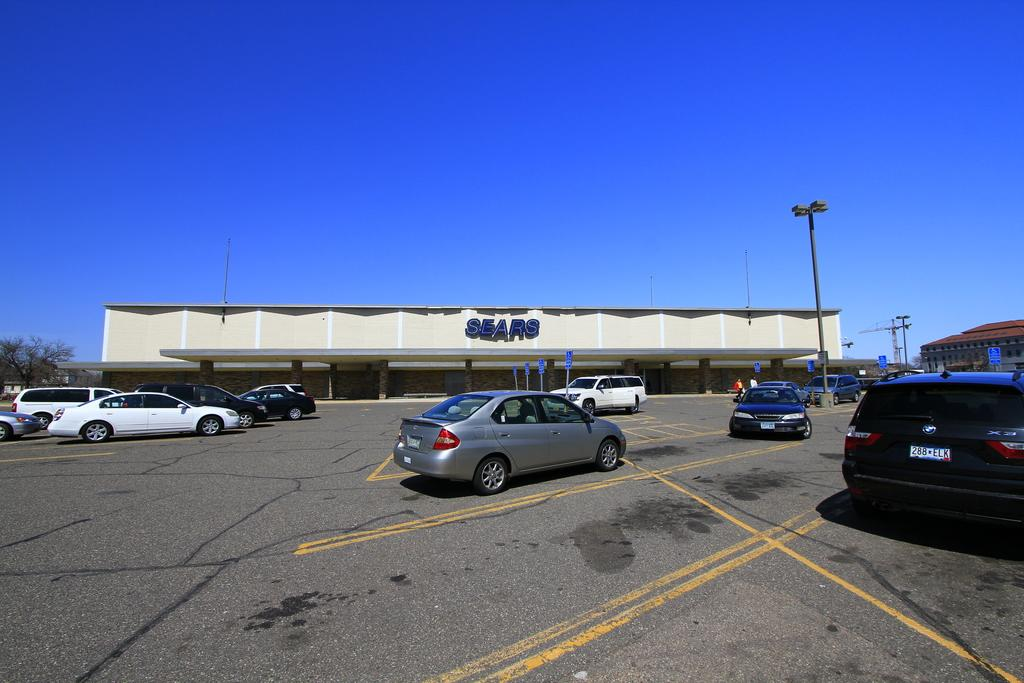What is happening on the road in the image? There are vehicles on the road in the image. What can be seen in the distance behind the vehicles? There are buildings, trees, pole lights, and the sky visible in the background of the image. Can you see a boy hiding behind the linen in the image? There is no boy or linen present in the image. 